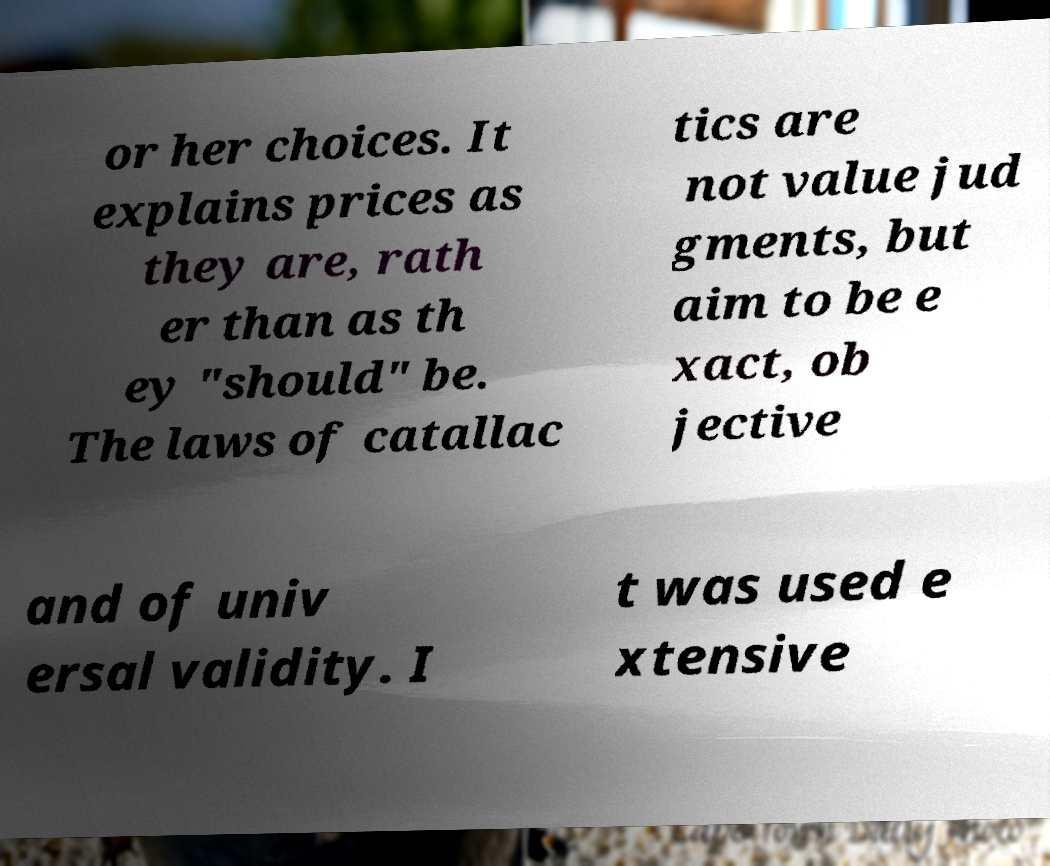Can you read and provide the text displayed in the image?This photo seems to have some interesting text. Can you extract and type it out for me? or her choices. It explains prices as they are, rath er than as th ey "should" be. The laws of catallac tics are not value jud gments, but aim to be e xact, ob jective and of univ ersal validity. I t was used e xtensive 